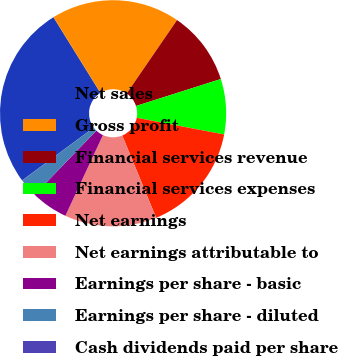Convert chart to OTSL. <chart><loc_0><loc_0><loc_500><loc_500><pie_chart><fcel>Net sales<fcel>Gross profit<fcel>Financial services revenue<fcel>Financial services expenses<fcel>Net earnings<fcel>Net earnings attributable to<fcel>Earnings per share - basic<fcel>Earnings per share - diluted<fcel>Cash dividends paid per share<nl><fcel>26.28%<fcel>18.41%<fcel>10.53%<fcel>7.9%<fcel>15.78%<fcel>13.15%<fcel>5.28%<fcel>2.65%<fcel>0.02%<nl></chart> 